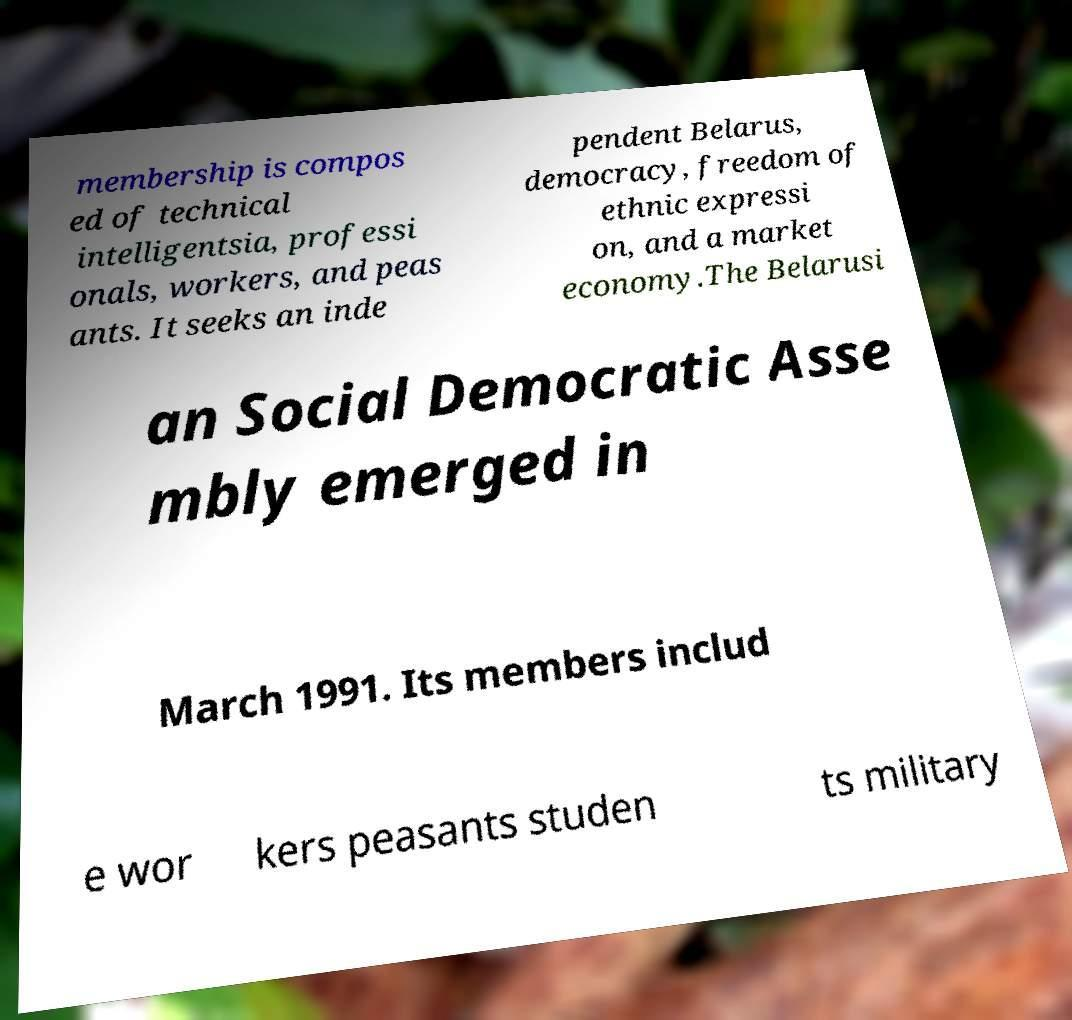What messages or text are displayed in this image? I need them in a readable, typed format. membership is compos ed of technical intelligentsia, professi onals, workers, and peas ants. It seeks an inde pendent Belarus, democracy, freedom of ethnic expressi on, and a market economy.The Belarusi an Social Democratic Asse mbly emerged in March 1991. Its members includ e wor kers peasants studen ts military 